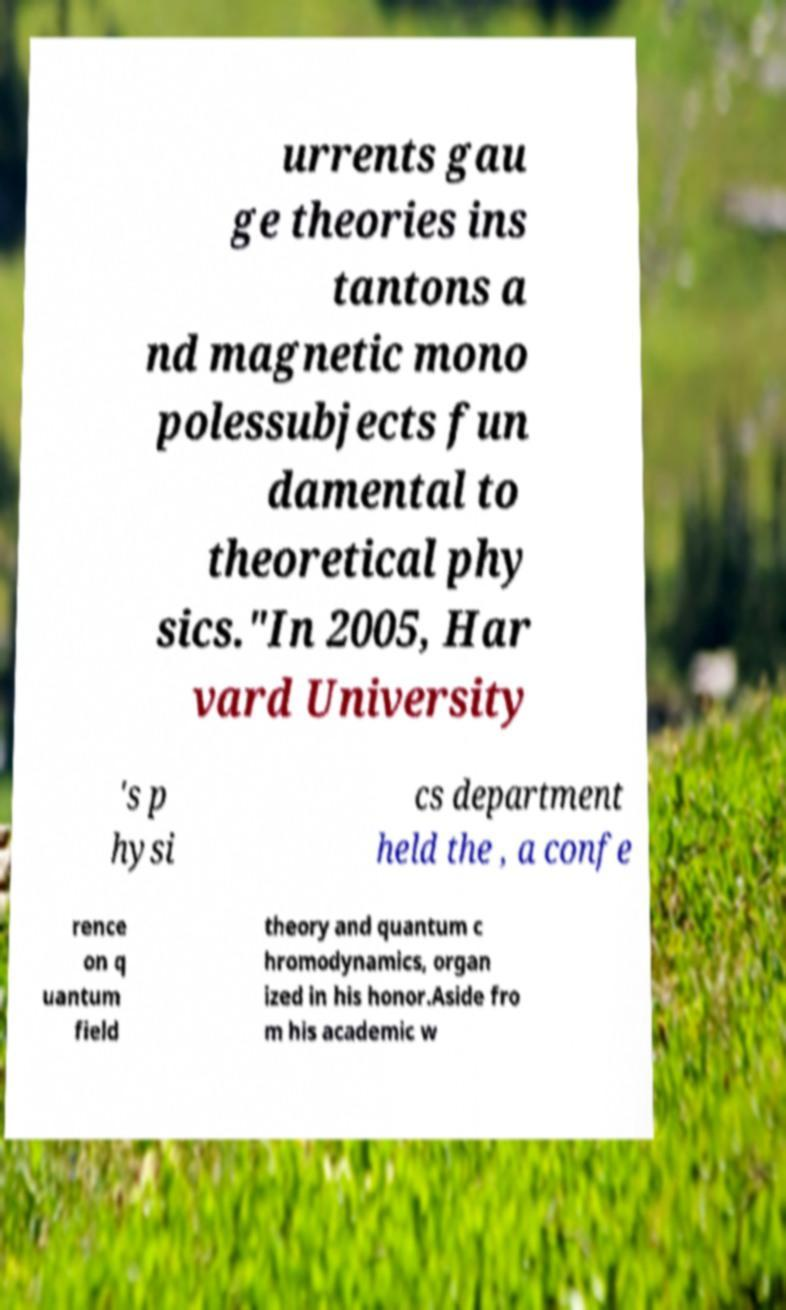Please identify and transcribe the text found in this image. urrents gau ge theories ins tantons a nd magnetic mono polessubjects fun damental to theoretical phy sics."In 2005, Har vard University 's p hysi cs department held the , a confe rence on q uantum field theory and quantum c hromodynamics, organ ized in his honor.Aside fro m his academic w 